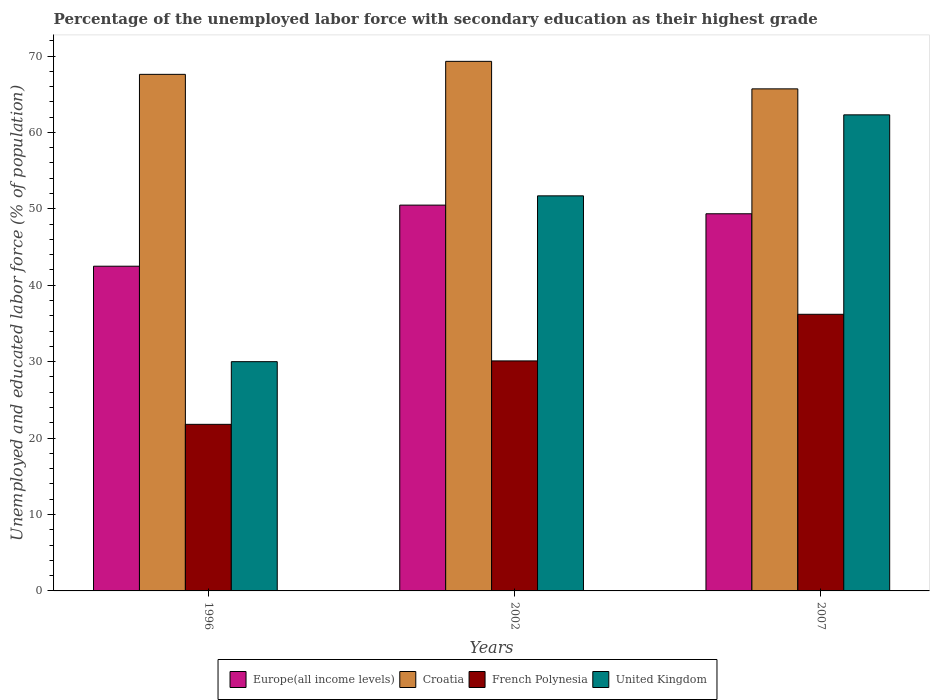How many different coloured bars are there?
Keep it short and to the point. 4. Are the number of bars per tick equal to the number of legend labels?
Your response must be concise. Yes. Are the number of bars on each tick of the X-axis equal?
Your response must be concise. Yes. How many bars are there on the 3rd tick from the left?
Keep it short and to the point. 4. How many bars are there on the 2nd tick from the right?
Your answer should be very brief. 4. What is the label of the 3rd group of bars from the left?
Keep it short and to the point. 2007. In how many cases, is the number of bars for a given year not equal to the number of legend labels?
Offer a very short reply. 0. What is the percentage of the unemployed labor force with secondary education in United Kingdom in 2002?
Your answer should be very brief. 51.7. Across all years, what is the maximum percentage of the unemployed labor force with secondary education in Europe(all income levels)?
Give a very brief answer. 50.49. Across all years, what is the minimum percentage of the unemployed labor force with secondary education in Europe(all income levels)?
Your response must be concise. 42.49. What is the total percentage of the unemployed labor force with secondary education in Europe(all income levels) in the graph?
Offer a very short reply. 142.33. What is the difference between the percentage of the unemployed labor force with secondary education in Croatia in 1996 and that in 2007?
Keep it short and to the point. 1.9. What is the difference between the percentage of the unemployed labor force with secondary education in Croatia in 2007 and the percentage of the unemployed labor force with secondary education in United Kingdom in 1996?
Your answer should be very brief. 35.7. In the year 2007, what is the difference between the percentage of the unemployed labor force with secondary education in United Kingdom and percentage of the unemployed labor force with secondary education in Europe(all income levels)?
Your response must be concise. 12.94. In how many years, is the percentage of the unemployed labor force with secondary education in French Polynesia greater than 34 %?
Your answer should be compact. 1. What is the ratio of the percentage of the unemployed labor force with secondary education in French Polynesia in 1996 to that in 2002?
Keep it short and to the point. 0.72. Is the percentage of the unemployed labor force with secondary education in French Polynesia in 2002 less than that in 2007?
Your response must be concise. Yes. What is the difference between the highest and the second highest percentage of the unemployed labor force with secondary education in United Kingdom?
Your answer should be very brief. 10.6. What is the difference between the highest and the lowest percentage of the unemployed labor force with secondary education in Croatia?
Offer a very short reply. 3.6. In how many years, is the percentage of the unemployed labor force with secondary education in Europe(all income levels) greater than the average percentage of the unemployed labor force with secondary education in Europe(all income levels) taken over all years?
Offer a terse response. 2. Is the sum of the percentage of the unemployed labor force with secondary education in United Kingdom in 1996 and 2002 greater than the maximum percentage of the unemployed labor force with secondary education in Europe(all income levels) across all years?
Your answer should be compact. Yes. Is it the case that in every year, the sum of the percentage of the unemployed labor force with secondary education in Europe(all income levels) and percentage of the unemployed labor force with secondary education in French Polynesia is greater than the sum of percentage of the unemployed labor force with secondary education in United Kingdom and percentage of the unemployed labor force with secondary education in Croatia?
Offer a very short reply. No. What does the 3rd bar from the left in 2007 represents?
Your answer should be very brief. French Polynesia. What does the 3rd bar from the right in 2002 represents?
Offer a terse response. Croatia. Is it the case that in every year, the sum of the percentage of the unemployed labor force with secondary education in Croatia and percentage of the unemployed labor force with secondary education in Europe(all income levels) is greater than the percentage of the unemployed labor force with secondary education in French Polynesia?
Provide a short and direct response. Yes. Are all the bars in the graph horizontal?
Your response must be concise. No. How many years are there in the graph?
Provide a short and direct response. 3. What is the difference between two consecutive major ticks on the Y-axis?
Offer a terse response. 10. Does the graph contain any zero values?
Ensure brevity in your answer.  No. Does the graph contain grids?
Your answer should be very brief. No. Where does the legend appear in the graph?
Your response must be concise. Bottom center. How many legend labels are there?
Provide a succinct answer. 4. How are the legend labels stacked?
Provide a succinct answer. Horizontal. What is the title of the graph?
Offer a terse response. Percentage of the unemployed labor force with secondary education as their highest grade. Does "Tunisia" appear as one of the legend labels in the graph?
Offer a terse response. No. What is the label or title of the Y-axis?
Offer a very short reply. Unemployed and educated labor force (% of population). What is the Unemployed and educated labor force (% of population) of Europe(all income levels) in 1996?
Ensure brevity in your answer.  42.49. What is the Unemployed and educated labor force (% of population) in Croatia in 1996?
Provide a succinct answer. 67.6. What is the Unemployed and educated labor force (% of population) in French Polynesia in 1996?
Offer a very short reply. 21.8. What is the Unemployed and educated labor force (% of population) of United Kingdom in 1996?
Offer a very short reply. 30. What is the Unemployed and educated labor force (% of population) of Europe(all income levels) in 2002?
Keep it short and to the point. 50.49. What is the Unemployed and educated labor force (% of population) of Croatia in 2002?
Give a very brief answer. 69.3. What is the Unemployed and educated labor force (% of population) in French Polynesia in 2002?
Your response must be concise. 30.1. What is the Unemployed and educated labor force (% of population) in United Kingdom in 2002?
Your answer should be very brief. 51.7. What is the Unemployed and educated labor force (% of population) in Europe(all income levels) in 2007?
Make the answer very short. 49.36. What is the Unemployed and educated labor force (% of population) of Croatia in 2007?
Keep it short and to the point. 65.7. What is the Unemployed and educated labor force (% of population) of French Polynesia in 2007?
Your answer should be compact. 36.2. What is the Unemployed and educated labor force (% of population) in United Kingdom in 2007?
Offer a terse response. 62.3. Across all years, what is the maximum Unemployed and educated labor force (% of population) of Europe(all income levels)?
Your answer should be very brief. 50.49. Across all years, what is the maximum Unemployed and educated labor force (% of population) in Croatia?
Your answer should be compact. 69.3. Across all years, what is the maximum Unemployed and educated labor force (% of population) in French Polynesia?
Keep it short and to the point. 36.2. Across all years, what is the maximum Unemployed and educated labor force (% of population) in United Kingdom?
Ensure brevity in your answer.  62.3. Across all years, what is the minimum Unemployed and educated labor force (% of population) in Europe(all income levels)?
Offer a terse response. 42.49. Across all years, what is the minimum Unemployed and educated labor force (% of population) in Croatia?
Your response must be concise. 65.7. Across all years, what is the minimum Unemployed and educated labor force (% of population) of French Polynesia?
Offer a very short reply. 21.8. Across all years, what is the minimum Unemployed and educated labor force (% of population) in United Kingdom?
Offer a terse response. 30. What is the total Unemployed and educated labor force (% of population) of Europe(all income levels) in the graph?
Make the answer very short. 142.33. What is the total Unemployed and educated labor force (% of population) of Croatia in the graph?
Offer a terse response. 202.6. What is the total Unemployed and educated labor force (% of population) of French Polynesia in the graph?
Offer a very short reply. 88.1. What is the total Unemployed and educated labor force (% of population) in United Kingdom in the graph?
Make the answer very short. 144. What is the difference between the Unemployed and educated labor force (% of population) in Europe(all income levels) in 1996 and that in 2002?
Ensure brevity in your answer.  -8. What is the difference between the Unemployed and educated labor force (% of population) in United Kingdom in 1996 and that in 2002?
Your answer should be compact. -21.7. What is the difference between the Unemployed and educated labor force (% of population) of Europe(all income levels) in 1996 and that in 2007?
Provide a succinct answer. -6.86. What is the difference between the Unemployed and educated labor force (% of population) in Croatia in 1996 and that in 2007?
Ensure brevity in your answer.  1.9. What is the difference between the Unemployed and educated labor force (% of population) of French Polynesia in 1996 and that in 2007?
Ensure brevity in your answer.  -14.4. What is the difference between the Unemployed and educated labor force (% of population) in United Kingdom in 1996 and that in 2007?
Your answer should be very brief. -32.3. What is the difference between the Unemployed and educated labor force (% of population) of Europe(all income levels) in 2002 and that in 2007?
Your answer should be compact. 1.13. What is the difference between the Unemployed and educated labor force (% of population) in Croatia in 2002 and that in 2007?
Offer a terse response. 3.6. What is the difference between the Unemployed and educated labor force (% of population) of French Polynesia in 2002 and that in 2007?
Provide a succinct answer. -6.1. What is the difference between the Unemployed and educated labor force (% of population) in Europe(all income levels) in 1996 and the Unemployed and educated labor force (% of population) in Croatia in 2002?
Provide a succinct answer. -26.81. What is the difference between the Unemployed and educated labor force (% of population) of Europe(all income levels) in 1996 and the Unemployed and educated labor force (% of population) of French Polynesia in 2002?
Provide a succinct answer. 12.39. What is the difference between the Unemployed and educated labor force (% of population) in Europe(all income levels) in 1996 and the Unemployed and educated labor force (% of population) in United Kingdom in 2002?
Provide a succinct answer. -9.21. What is the difference between the Unemployed and educated labor force (% of population) of Croatia in 1996 and the Unemployed and educated labor force (% of population) of French Polynesia in 2002?
Make the answer very short. 37.5. What is the difference between the Unemployed and educated labor force (% of population) of Croatia in 1996 and the Unemployed and educated labor force (% of population) of United Kingdom in 2002?
Keep it short and to the point. 15.9. What is the difference between the Unemployed and educated labor force (% of population) of French Polynesia in 1996 and the Unemployed and educated labor force (% of population) of United Kingdom in 2002?
Make the answer very short. -29.9. What is the difference between the Unemployed and educated labor force (% of population) of Europe(all income levels) in 1996 and the Unemployed and educated labor force (% of population) of Croatia in 2007?
Your response must be concise. -23.21. What is the difference between the Unemployed and educated labor force (% of population) of Europe(all income levels) in 1996 and the Unemployed and educated labor force (% of population) of French Polynesia in 2007?
Provide a succinct answer. 6.29. What is the difference between the Unemployed and educated labor force (% of population) of Europe(all income levels) in 1996 and the Unemployed and educated labor force (% of population) of United Kingdom in 2007?
Provide a succinct answer. -19.81. What is the difference between the Unemployed and educated labor force (% of population) in Croatia in 1996 and the Unemployed and educated labor force (% of population) in French Polynesia in 2007?
Offer a terse response. 31.4. What is the difference between the Unemployed and educated labor force (% of population) of French Polynesia in 1996 and the Unemployed and educated labor force (% of population) of United Kingdom in 2007?
Your answer should be very brief. -40.5. What is the difference between the Unemployed and educated labor force (% of population) of Europe(all income levels) in 2002 and the Unemployed and educated labor force (% of population) of Croatia in 2007?
Provide a short and direct response. -15.21. What is the difference between the Unemployed and educated labor force (% of population) in Europe(all income levels) in 2002 and the Unemployed and educated labor force (% of population) in French Polynesia in 2007?
Keep it short and to the point. 14.29. What is the difference between the Unemployed and educated labor force (% of population) of Europe(all income levels) in 2002 and the Unemployed and educated labor force (% of population) of United Kingdom in 2007?
Ensure brevity in your answer.  -11.81. What is the difference between the Unemployed and educated labor force (% of population) of Croatia in 2002 and the Unemployed and educated labor force (% of population) of French Polynesia in 2007?
Make the answer very short. 33.1. What is the difference between the Unemployed and educated labor force (% of population) in Croatia in 2002 and the Unemployed and educated labor force (% of population) in United Kingdom in 2007?
Give a very brief answer. 7. What is the difference between the Unemployed and educated labor force (% of population) of French Polynesia in 2002 and the Unemployed and educated labor force (% of population) of United Kingdom in 2007?
Provide a succinct answer. -32.2. What is the average Unemployed and educated labor force (% of population) of Europe(all income levels) per year?
Provide a succinct answer. 47.44. What is the average Unemployed and educated labor force (% of population) of Croatia per year?
Provide a succinct answer. 67.53. What is the average Unemployed and educated labor force (% of population) in French Polynesia per year?
Give a very brief answer. 29.37. What is the average Unemployed and educated labor force (% of population) of United Kingdom per year?
Keep it short and to the point. 48. In the year 1996, what is the difference between the Unemployed and educated labor force (% of population) in Europe(all income levels) and Unemployed and educated labor force (% of population) in Croatia?
Your answer should be compact. -25.11. In the year 1996, what is the difference between the Unemployed and educated labor force (% of population) of Europe(all income levels) and Unemployed and educated labor force (% of population) of French Polynesia?
Ensure brevity in your answer.  20.69. In the year 1996, what is the difference between the Unemployed and educated labor force (% of population) in Europe(all income levels) and Unemployed and educated labor force (% of population) in United Kingdom?
Keep it short and to the point. 12.49. In the year 1996, what is the difference between the Unemployed and educated labor force (% of population) of Croatia and Unemployed and educated labor force (% of population) of French Polynesia?
Your response must be concise. 45.8. In the year 1996, what is the difference between the Unemployed and educated labor force (% of population) of Croatia and Unemployed and educated labor force (% of population) of United Kingdom?
Provide a succinct answer. 37.6. In the year 2002, what is the difference between the Unemployed and educated labor force (% of population) of Europe(all income levels) and Unemployed and educated labor force (% of population) of Croatia?
Your answer should be very brief. -18.81. In the year 2002, what is the difference between the Unemployed and educated labor force (% of population) in Europe(all income levels) and Unemployed and educated labor force (% of population) in French Polynesia?
Offer a very short reply. 20.39. In the year 2002, what is the difference between the Unemployed and educated labor force (% of population) in Europe(all income levels) and Unemployed and educated labor force (% of population) in United Kingdom?
Provide a succinct answer. -1.21. In the year 2002, what is the difference between the Unemployed and educated labor force (% of population) of Croatia and Unemployed and educated labor force (% of population) of French Polynesia?
Your answer should be very brief. 39.2. In the year 2002, what is the difference between the Unemployed and educated labor force (% of population) in Croatia and Unemployed and educated labor force (% of population) in United Kingdom?
Offer a terse response. 17.6. In the year 2002, what is the difference between the Unemployed and educated labor force (% of population) of French Polynesia and Unemployed and educated labor force (% of population) of United Kingdom?
Your response must be concise. -21.6. In the year 2007, what is the difference between the Unemployed and educated labor force (% of population) in Europe(all income levels) and Unemployed and educated labor force (% of population) in Croatia?
Make the answer very short. -16.34. In the year 2007, what is the difference between the Unemployed and educated labor force (% of population) in Europe(all income levels) and Unemployed and educated labor force (% of population) in French Polynesia?
Offer a very short reply. 13.16. In the year 2007, what is the difference between the Unemployed and educated labor force (% of population) of Europe(all income levels) and Unemployed and educated labor force (% of population) of United Kingdom?
Offer a terse response. -12.94. In the year 2007, what is the difference between the Unemployed and educated labor force (% of population) in Croatia and Unemployed and educated labor force (% of population) in French Polynesia?
Offer a very short reply. 29.5. In the year 2007, what is the difference between the Unemployed and educated labor force (% of population) in Croatia and Unemployed and educated labor force (% of population) in United Kingdom?
Ensure brevity in your answer.  3.4. In the year 2007, what is the difference between the Unemployed and educated labor force (% of population) of French Polynesia and Unemployed and educated labor force (% of population) of United Kingdom?
Make the answer very short. -26.1. What is the ratio of the Unemployed and educated labor force (% of population) in Europe(all income levels) in 1996 to that in 2002?
Ensure brevity in your answer.  0.84. What is the ratio of the Unemployed and educated labor force (% of population) in Croatia in 1996 to that in 2002?
Your answer should be very brief. 0.98. What is the ratio of the Unemployed and educated labor force (% of population) of French Polynesia in 1996 to that in 2002?
Offer a very short reply. 0.72. What is the ratio of the Unemployed and educated labor force (% of population) of United Kingdom in 1996 to that in 2002?
Offer a very short reply. 0.58. What is the ratio of the Unemployed and educated labor force (% of population) in Europe(all income levels) in 1996 to that in 2007?
Your response must be concise. 0.86. What is the ratio of the Unemployed and educated labor force (% of population) in Croatia in 1996 to that in 2007?
Make the answer very short. 1.03. What is the ratio of the Unemployed and educated labor force (% of population) of French Polynesia in 1996 to that in 2007?
Give a very brief answer. 0.6. What is the ratio of the Unemployed and educated labor force (% of population) in United Kingdom in 1996 to that in 2007?
Ensure brevity in your answer.  0.48. What is the ratio of the Unemployed and educated labor force (% of population) of Europe(all income levels) in 2002 to that in 2007?
Your answer should be compact. 1.02. What is the ratio of the Unemployed and educated labor force (% of population) of Croatia in 2002 to that in 2007?
Offer a terse response. 1.05. What is the ratio of the Unemployed and educated labor force (% of population) of French Polynesia in 2002 to that in 2007?
Give a very brief answer. 0.83. What is the ratio of the Unemployed and educated labor force (% of population) of United Kingdom in 2002 to that in 2007?
Your answer should be very brief. 0.83. What is the difference between the highest and the second highest Unemployed and educated labor force (% of population) in Europe(all income levels)?
Provide a succinct answer. 1.13. What is the difference between the highest and the second highest Unemployed and educated labor force (% of population) in United Kingdom?
Give a very brief answer. 10.6. What is the difference between the highest and the lowest Unemployed and educated labor force (% of population) in Europe(all income levels)?
Your response must be concise. 8. What is the difference between the highest and the lowest Unemployed and educated labor force (% of population) of French Polynesia?
Offer a very short reply. 14.4. What is the difference between the highest and the lowest Unemployed and educated labor force (% of population) of United Kingdom?
Your answer should be compact. 32.3. 